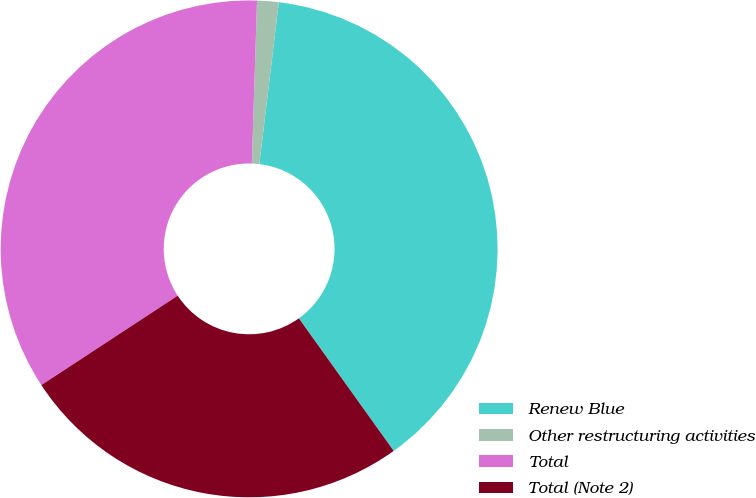<chart> <loc_0><loc_0><loc_500><loc_500><pie_chart><fcel>Renew Blue<fcel>Other restructuring activities<fcel>Total<fcel>Total (Note 2)<nl><fcel>38.21%<fcel>1.4%<fcel>34.74%<fcel>25.65%<nl></chart> 